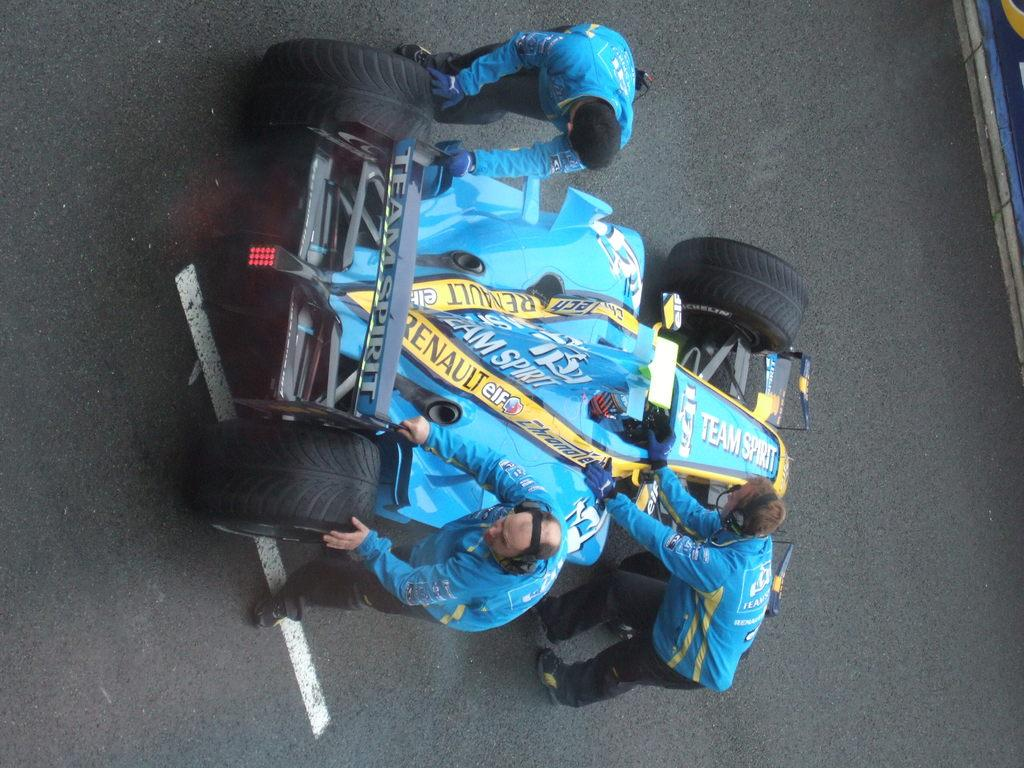What is the main subject of the image? The main subject of the image is a race car. What are the people in the image doing? Four persons are moving the race car in the image. Where are the people and the race car located? The persons and the race car are on the road. Can you describe the clothing of one of the persons? One person is wearing a blue color jacket. What type of haircut does the fowl have in the image? There is no fowl present in the image, so it is not possible to describe its haircut. 